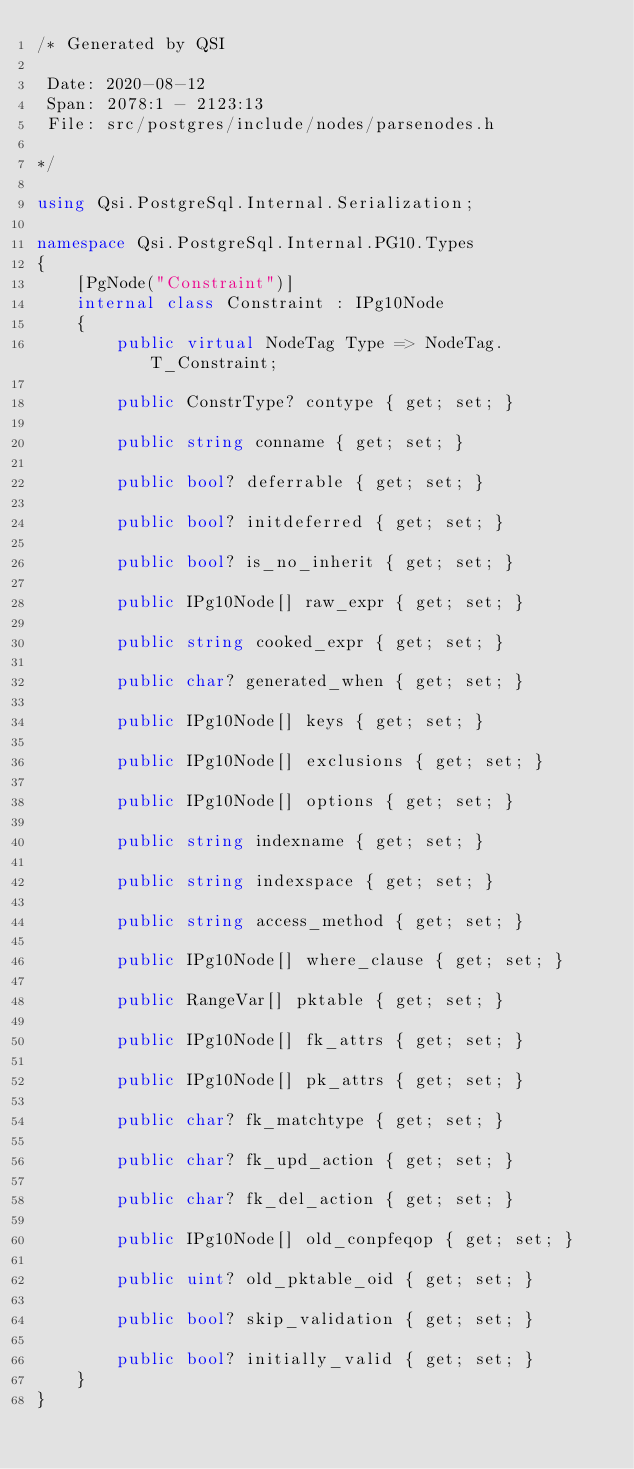<code> <loc_0><loc_0><loc_500><loc_500><_C#_>/* Generated by QSI

 Date: 2020-08-12
 Span: 2078:1 - 2123:13
 File: src/postgres/include/nodes/parsenodes.h

*/

using Qsi.PostgreSql.Internal.Serialization;

namespace Qsi.PostgreSql.Internal.PG10.Types
{
    [PgNode("Constraint")]
    internal class Constraint : IPg10Node
    {
        public virtual NodeTag Type => NodeTag.T_Constraint;

        public ConstrType? contype { get; set; }

        public string conname { get; set; }

        public bool? deferrable { get; set; }

        public bool? initdeferred { get; set; }

        public bool? is_no_inherit { get; set; }

        public IPg10Node[] raw_expr { get; set; }

        public string cooked_expr { get; set; }

        public char? generated_when { get; set; }

        public IPg10Node[] keys { get; set; }

        public IPg10Node[] exclusions { get; set; }

        public IPg10Node[] options { get; set; }

        public string indexname { get; set; }

        public string indexspace { get; set; }

        public string access_method { get; set; }

        public IPg10Node[] where_clause { get; set; }

        public RangeVar[] pktable { get; set; }

        public IPg10Node[] fk_attrs { get; set; }

        public IPg10Node[] pk_attrs { get; set; }

        public char? fk_matchtype { get; set; }

        public char? fk_upd_action { get; set; }

        public char? fk_del_action { get; set; }

        public IPg10Node[] old_conpfeqop { get; set; }

        public uint? old_pktable_oid { get; set; }

        public bool? skip_validation { get; set; }

        public bool? initially_valid { get; set; }
    }
}
</code> 